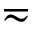Convert formula to latex. <formula><loc_0><loc_0><loc_500><loc_500>\eqsim</formula> 